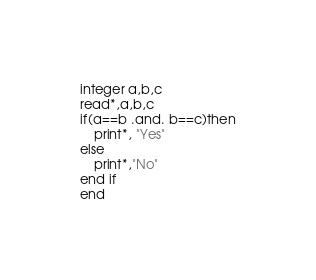<code> <loc_0><loc_0><loc_500><loc_500><_FORTRAN_>integer a,b,c
read*,a,b,c
if(a==b .and. b==c)then
	print*, "Yes"
else
	print*,"No"
end if
end</code> 